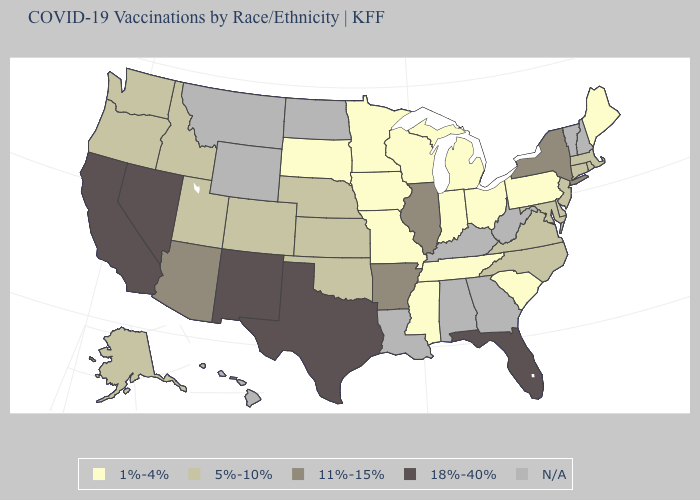What is the lowest value in the West?
Keep it brief. 5%-10%. Is the legend a continuous bar?
Give a very brief answer. No. Among the states that border Kansas , which have the lowest value?
Concise answer only. Missouri. What is the lowest value in states that border Alabama?
Give a very brief answer. 1%-4%. What is the lowest value in the Northeast?
Concise answer only. 1%-4%. What is the value of Massachusetts?
Keep it brief. 5%-10%. How many symbols are there in the legend?
Short answer required. 5. What is the lowest value in the USA?
Answer briefly. 1%-4%. What is the lowest value in the USA?
Concise answer only. 1%-4%. What is the value of Arizona?
Concise answer only. 11%-15%. What is the value of Kansas?
Give a very brief answer. 5%-10%. How many symbols are there in the legend?
Short answer required. 5. 